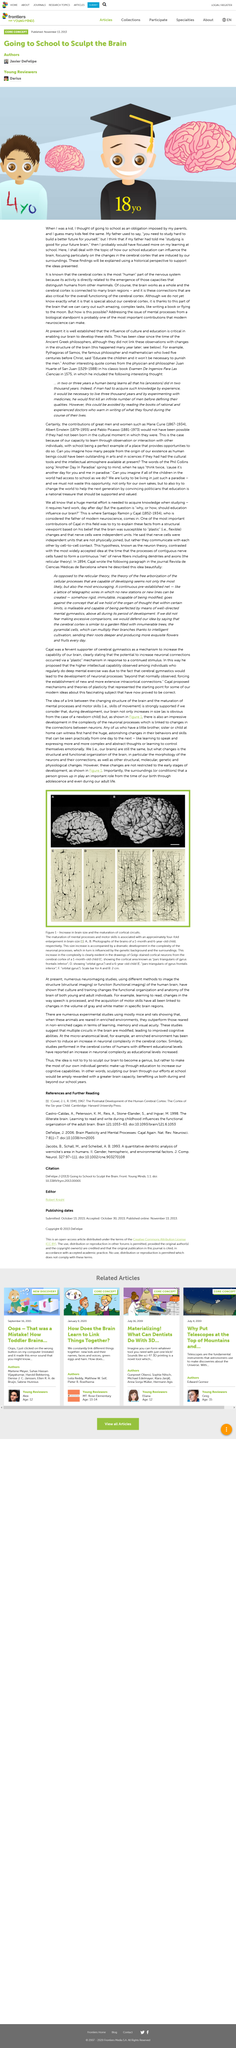Highlight a few significant elements in this photo. The author believes that if his father had followed a different approach, he may have studied more. The change in the representation of the cerebral cortex from a small youth brain to a larger adult brain is a notable difference. The findings are not current from the perspective of the current understanding. 